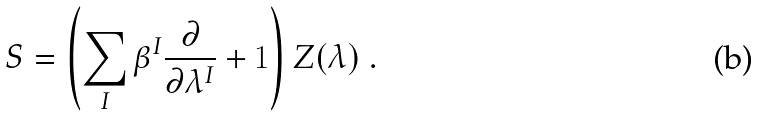Convert formula to latex. <formula><loc_0><loc_0><loc_500><loc_500>S = \left ( \sum _ { I } \beta ^ { I } \frac { \partial } { \partial \lambda ^ { I } } + 1 \right ) Z ( \lambda ) \ .</formula> 